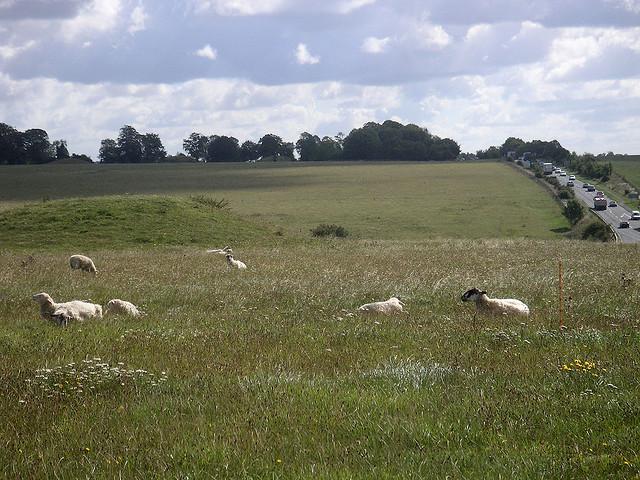Is that a black sheep in the field?
Be succinct. No. How many sheep are in the pasture?
Keep it brief. 7. How many sheep are in the picture?
Short answer required. 6. How many rocks are on the right?
Be succinct. 0. Does the cloud sort of look like a deity's brass knuckles?
Concise answer only. Yes. How many animals can be seen?
Be succinct. 7. Is the field close to a highway?
Concise answer only. Yes. Is this farm in a rural area?
Give a very brief answer. Yes. How many animals are laying down?
Concise answer only. 6. What kind of livestock is grazing the field?
Keep it brief. Sheep. How many white sheep are in this scene?
Concise answer only. 7. Are these sheep lost?
Write a very short answer. No. Have the sheep been recently shorn?
Quick response, please. Yes. Are there more than 10 animals in this photo?
Short answer required. No. What is the white round object on the ground?
Write a very short answer. Sheep. How many sheep?
Answer briefly. 6. Do you see any trees in the photo?
Be succinct. Yes. Is there water in the image?
Write a very short answer. No. How many birds are in this photo?
Keep it brief. 0. 